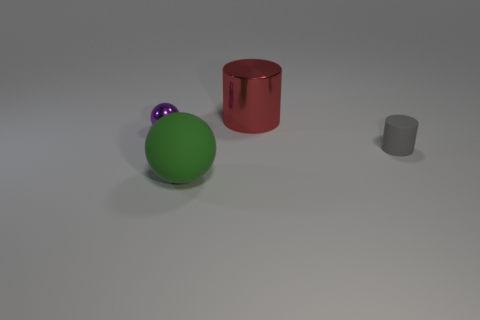Subtract 2 spheres. How many spheres are left? 0 Add 2 yellow metal blocks. How many objects exist? 6 Subtract all green spheres. How many spheres are left? 1 Subtract all large brown rubber balls. Subtract all big rubber objects. How many objects are left? 3 Add 1 green things. How many green things are left? 2 Add 4 gray rubber things. How many gray rubber things exist? 5 Subtract 0 brown cylinders. How many objects are left? 4 Subtract all yellow spheres. Subtract all cyan cylinders. How many spheres are left? 2 Subtract all gray spheres. How many gray cylinders are left? 1 